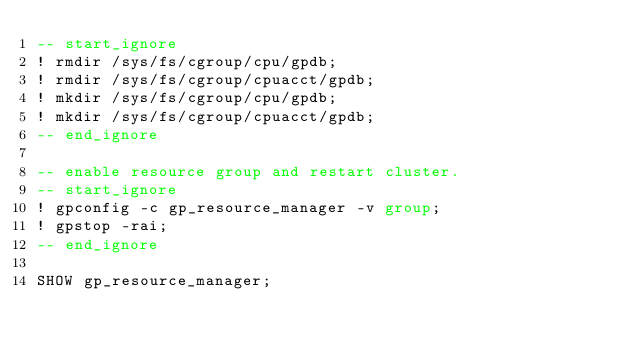Convert code to text. <code><loc_0><loc_0><loc_500><loc_500><_SQL_>-- start_ignore
! rmdir /sys/fs/cgroup/cpu/gpdb;
! rmdir /sys/fs/cgroup/cpuacct/gpdb;
! mkdir /sys/fs/cgroup/cpu/gpdb;
! mkdir /sys/fs/cgroup/cpuacct/gpdb;
-- end_ignore

-- enable resource group and restart cluster.
-- start_ignore
! gpconfig -c gp_resource_manager -v group;
! gpstop -rai;
-- end_ignore

SHOW gp_resource_manager;
</code> 